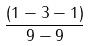Convert formula to latex. <formula><loc_0><loc_0><loc_500><loc_500>\frac { ( 1 - 3 - 1 ) } { 9 - 9 }</formula> 